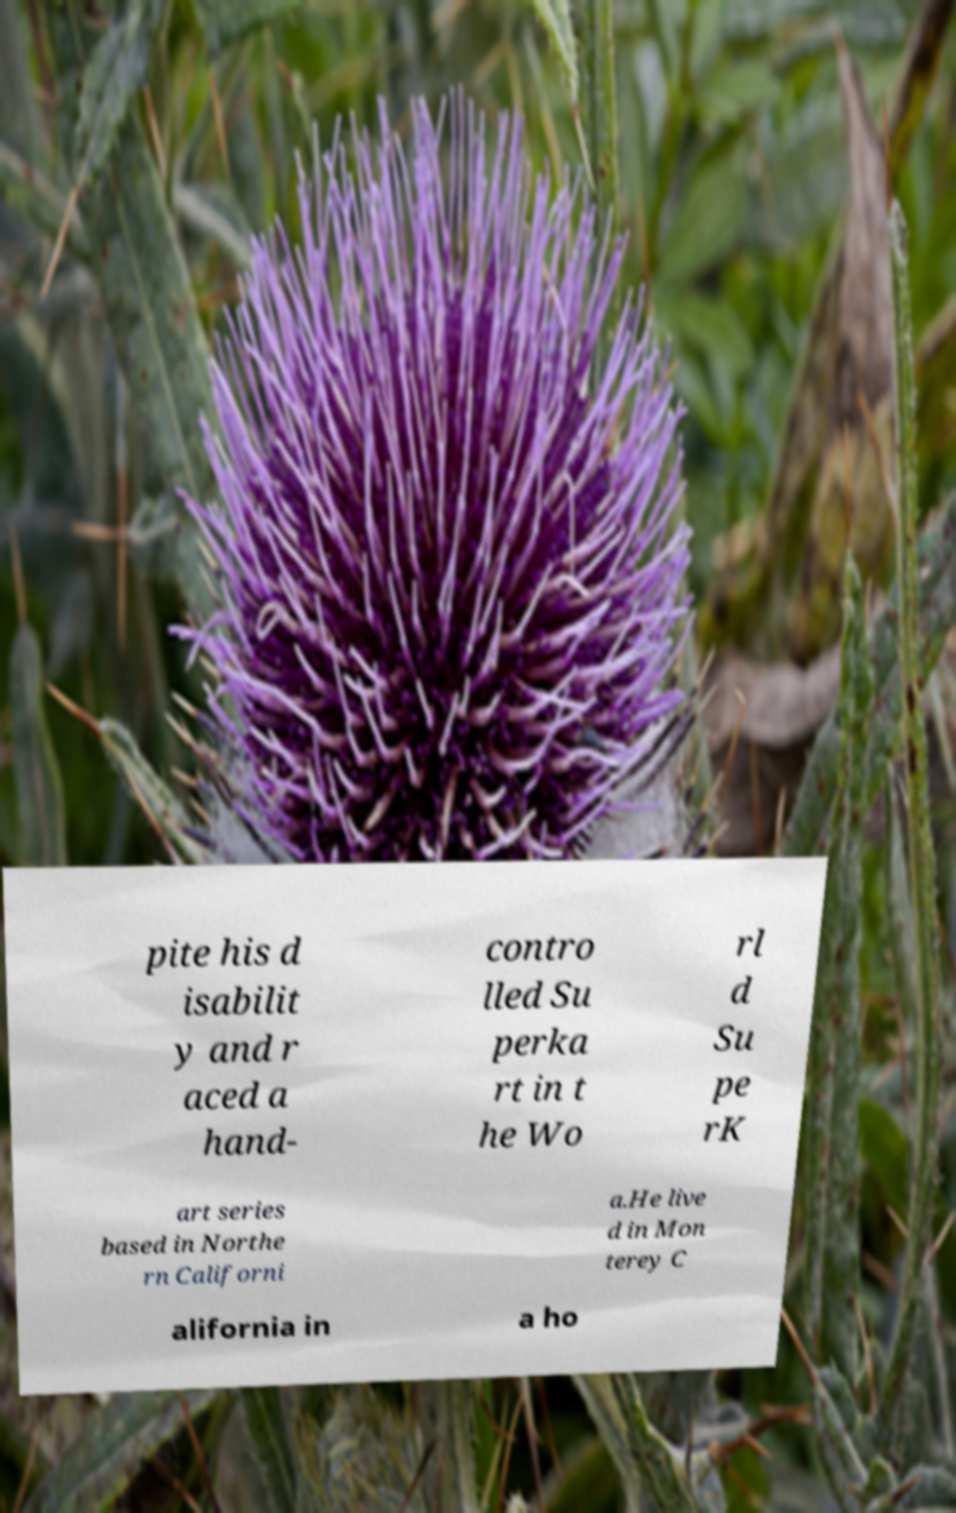What messages or text are displayed in this image? I need them in a readable, typed format. pite his d isabilit y and r aced a hand- contro lled Su perka rt in t he Wo rl d Su pe rK art series based in Northe rn Californi a.He live d in Mon terey C alifornia in a ho 